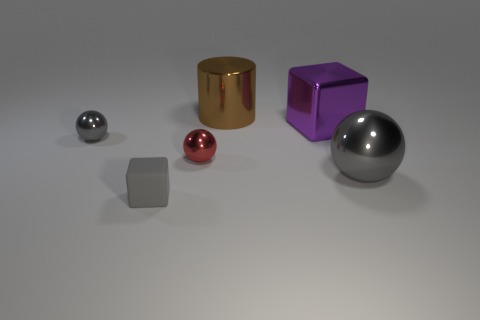What is the material of the tiny ball that is the same color as the tiny matte object? metal 